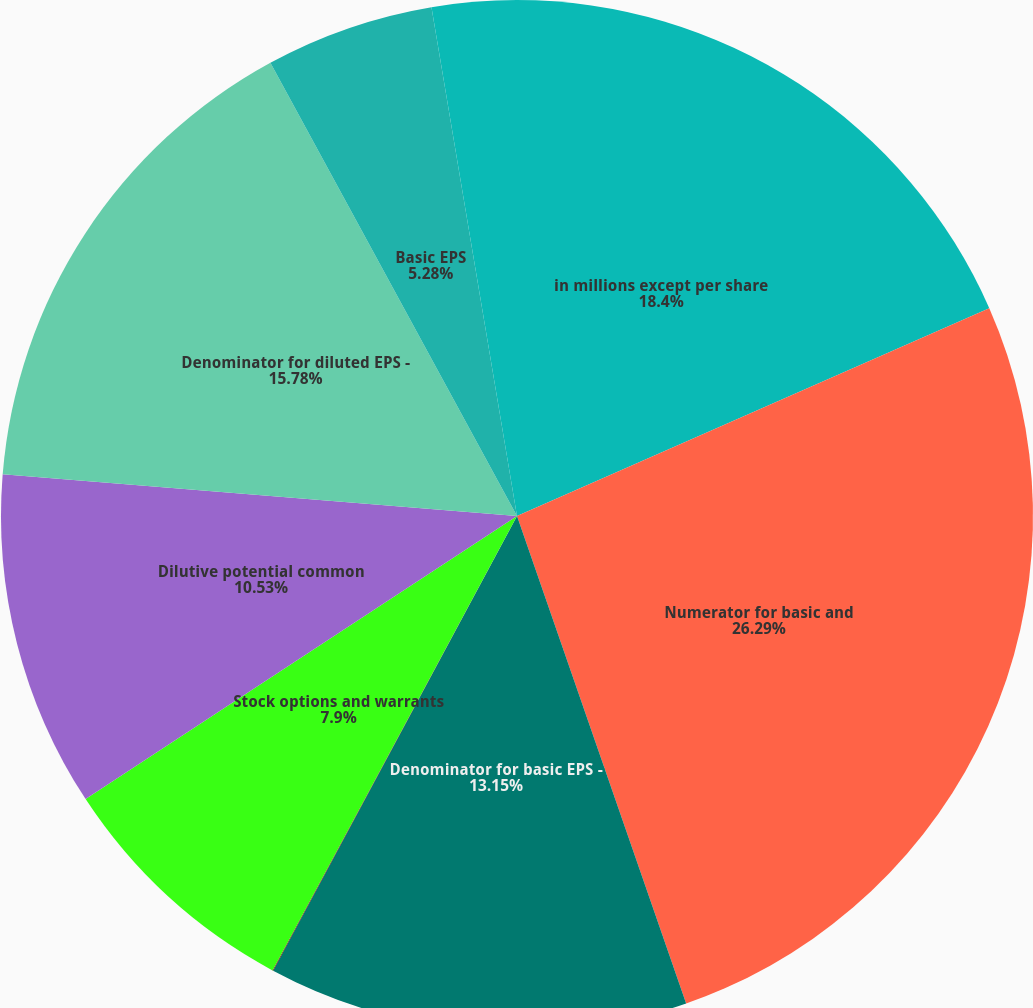Convert chart to OTSL. <chart><loc_0><loc_0><loc_500><loc_500><pie_chart><fcel>in millions except per share<fcel>Numerator for basic and<fcel>Denominator for basic EPS -<fcel>RSUs<fcel>Stock options and warrants<fcel>Dilutive potential common<fcel>Denominator for diluted EPS -<fcel>Basic EPS<fcel>Diluted EPS<nl><fcel>18.4%<fcel>26.28%<fcel>13.15%<fcel>0.02%<fcel>7.9%<fcel>10.53%<fcel>15.78%<fcel>5.28%<fcel>2.65%<nl></chart> 